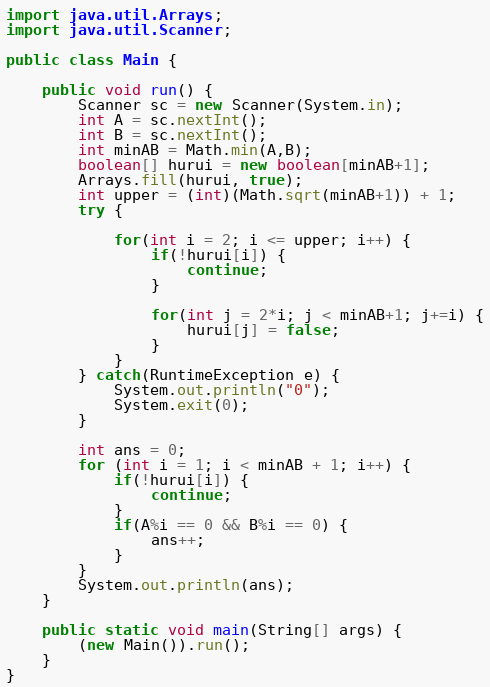<code> <loc_0><loc_0><loc_500><loc_500><_Java_>import java.util.Arrays;
import java.util.Scanner;

public class Main {

    public void run() {
        Scanner sc = new Scanner(System.in);
        int A = sc.nextInt();
        int B = sc.nextInt();
        int minAB = Math.min(A,B);
        boolean[] hurui = new boolean[minAB+1];
        Arrays.fill(hurui, true);
        int upper = (int)(Math.sqrt(minAB+1)) + 1;
        try {

            for(int i = 2; i <= upper; i++) {
                if(!hurui[i]) {
                    continue;
                }
                
                for(int j = 2*i; j < minAB+1; j+=i) {
                    hurui[j] = false;
                }
            }
        } catch(RuntimeException e) {
            System.out.println("0");
            System.exit(0);
        }

        int ans = 0;
        for (int i = 1; i < minAB + 1; i++) {
            if(!hurui[i]) {
                continue;
            }
            if(A%i == 0 && B%i == 0) {
                ans++;
            }
        }
        System.out.println(ans);
    }

    public static void main(String[] args) {
        (new Main()).run();
    }
}</code> 